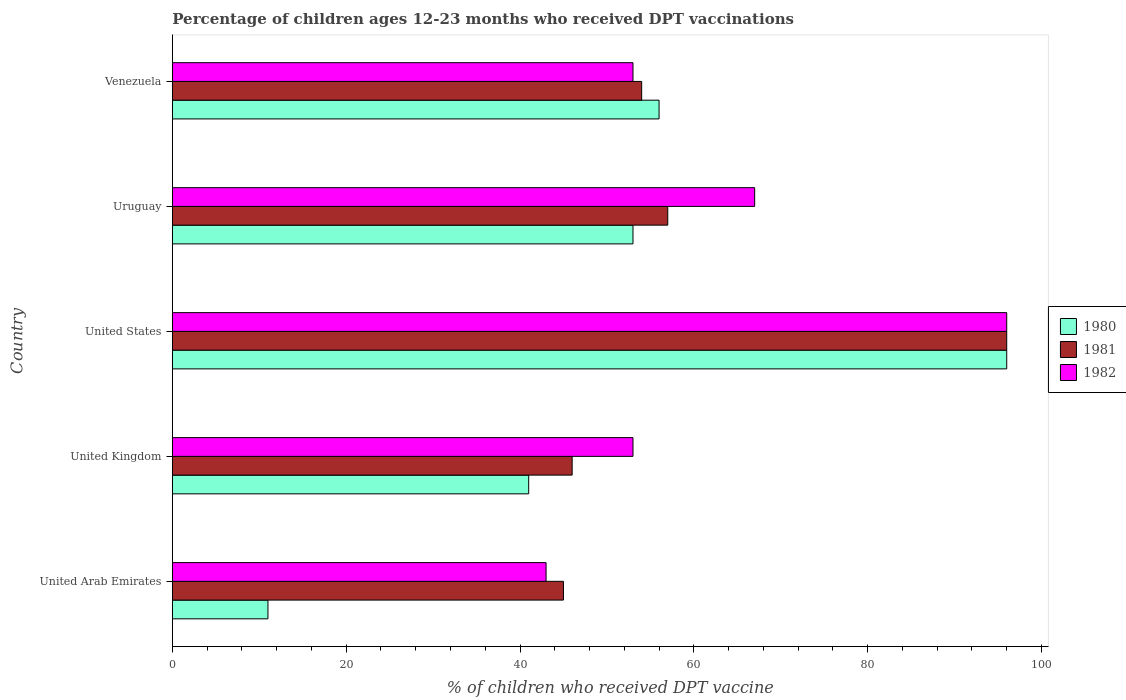How many groups of bars are there?
Offer a very short reply. 5. Are the number of bars on each tick of the Y-axis equal?
Ensure brevity in your answer.  Yes. How many bars are there on the 4th tick from the top?
Provide a succinct answer. 3. What is the label of the 5th group of bars from the top?
Give a very brief answer. United Arab Emirates. In how many cases, is the number of bars for a given country not equal to the number of legend labels?
Your answer should be compact. 0. What is the percentage of children who received DPT vaccination in 1980 in United Arab Emirates?
Keep it short and to the point. 11. Across all countries, what is the maximum percentage of children who received DPT vaccination in 1982?
Offer a terse response. 96. Across all countries, what is the minimum percentage of children who received DPT vaccination in 1982?
Ensure brevity in your answer.  43. In which country was the percentage of children who received DPT vaccination in 1982 maximum?
Provide a short and direct response. United States. In which country was the percentage of children who received DPT vaccination in 1981 minimum?
Offer a terse response. United Arab Emirates. What is the total percentage of children who received DPT vaccination in 1980 in the graph?
Offer a terse response. 257. What is the difference between the percentage of children who received DPT vaccination in 1981 in United Arab Emirates and the percentage of children who received DPT vaccination in 1980 in Uruguay?
Your response must be concise. -8. What is the average percentage of children who received DPT vaccination in 1980 per country?
Your answer should be very brief. 51.4. What is the difference between the percentage of children who received DPT vaccination in 1980 and percentage of children who received DPT vaccination in 1982 in United Kingdom?
Give a very brief answer. -12. In how many countries, is the percentage of children who received DPT vaccination in 1982 greater than 92 %?
Your answer should be very brief. 1. What is the ratio of the percentage of children who received DPT vaccination in 1982 in Uruguay to that in Venezuela?
Give a very brief answer. 1.26. Is the difference between the percentage of children who received DPT vaccination in 1980 in United Arab Emirates and United Kingdom greater than the difference between the percentage of children who received DPT vaccination in 1982 in United Arab Emirates and United Kingdom?
Provide a succinct answer. No. In how many countries, is the percentage of children who received DPT vaccination in 1980 greater than the average percentage of children who received DPT vaccination in 1980 taken over all countries?
Offer a very short reply. 3. Are all the bars in the graph horizontal?
Give a very brief answer. Yes. Are the values on the major ticks of X-axis written in scientific E-notation?
Your answer should be compact. No. How many legend labels are there?
Offer a terse response. 3. How are the legend labels stacked?
Make the answer very short. Vertical. What is the title of the graph?
Provide a succinct answer. Percentage of children ages 12-23 months who received DPT vaccinations. Does "2010" appear as one of the legend labels in the graph?
Your response must be concise. No. What is the label or title of the X-axis?
Your response must be concise. % of children who received DPT vaccine. What is the label or title of the Y-axis?
Your response must be concise. Country. What is the % of children who received DPT vaccine of 1980 in United Arab Emirates?
Provide a succinct answer. 11. What is the % of children who received DPT vaccine of 1980 in United Kingdom?
Provide a succinct answer. 41. What is the % of children who received DPT vaccine in 1982 in United Kingdom?
Offer a terse response. 53. What is the % of children who received DPT vaccine in 1980 in United States?
Offer a terse response. 96. What is the % of children who received DPT vaccine of 1981 in United States?
Your response must be concise. 96. What is the % of children who received DPT vaccine of 1982 in United States?
Offer a very short reply. 96. What is the % of children who received DPT vaccine of 1980 in Uruguay?
Your answer should be compact. 53. What is the % of children who received DPT vaccine in 1981 in Uruguay?
Offer a terse response. 57. What is the % of children who received DPT vaccine in 1980 in Venezuela?
Your answer should be very brief. 56. What is the % of children who received DPT vaccine in 1981 in Venezuela?
Your answer should be compact. 54. Across all countries, what is the maximum % of children who received DPT vaccine of 1980?
Your answer should be compact. 96. Across all countries, what is the maximum % of children who received DPT vaccine of 1981?
Your answer should be compact. 96. Across all countries, what is the maximum % of children who received DPT vaccine of 1982?
Offer a terse response. 96. Across all countries, what is the minimum % of children who received DPT vaccine of 1980?
Ensure brevity in your answer.  11. Across all countries, what is the minimum % of children who received DPT vaccine of 1981?
Your answer should be very brief. 45. Across all countries, what is the minimum % of children who received DPT vaccine in 1982?
Keep it short and to the point. 43. What is the total % of children who received DPT vaccine in 1980 in the graph?
Keep it short and to the point. 257. What is the total % of children who received DPT vaccine in 1981 in the graph?
Offer a terse response. 298. What is the total % of children who received DPT vaccine in 1982 in the graph?
Ensure brevity in your answer.  312. What is the difference between the % of children who received DPT vaccine in 1982 in United Arab Emirates and that in United Kingdom?
Offer a very short reply. -10. What is the difference between the % of children who received DPT vaccine of 1980 in United Arab Emirates and that in United States?
Make the answer very short. -85. What is the difference between the % of children who received DPT vaccine of 1981 in United Arab Emirates and that in United States?
Make the answer very short. -51. What is the difference between the % of children who received DPT vaccine of 1982 in United Arab Emirates and that in United States?
Provide a succinct answer. -53. What is the difference between the % of children who received DPT vaccine of 1980 in United Arab Emirates and that in Uruguay?
Offer a very short reply. -42. What is the difference between the % of children who received DPT vaccine of 1981 in United Arab Emirates and that in Uruguay?
Provide a short and direct response. -12. What is the difference between the % of children who received DPT vaccine of 1980 in United Arab Emirates and that in Venezuela?
Your response must be concise. -45. What is the difference between the % of children who received DPT vaccine of 1980 in United Kingdom and that in United States?
Provide a succinct answer. -55. What is the difference between the % of children who received DPT vaccine of 1981 in United Kingdom and that in United States?
Provide a succinct answer. -50. What is the difference between the % of children who received DPT vaccine of 1982 in United Kingdom and that in United States?
Give a very brief answer. -43. What is the difference between the % of children who received DPT vaccine of 1980 in United Kingdom and that in Uruguay?
Offer a terse response. -12. What is the difference between the % of children who received DPT vaccine in 1981 in United Kingdom and that in Uruguay?
Offer a terse response. -11. What is the difference between the % of children who received DPT vaccine of 1981 in United States and that in Venezuela?
Your answer should be very brief. 42. What is the difference between the % of children who received DPT vaccine of 1982 in United States and that in Venezuela?
Keep it short and to the point. 43. What is the difference between the % of children who received DPT vaccine of 1980 in Uruguay and that in Venezuela?
Keep it short and to the point. -3. What is the difference between the % of children who received DPT vaccine in 1980 in United Arab Emirates and the % of children who received DPT vaccine in 1981 in United Kingdom?
Provide a succinct answer. -35. What is the difference between the % of children who received DPT vaccine of 1980 in United Arab Emirates and the % of children who received DPT vaccine of 1982 in United Kingdom?
Your response must be concise. -42. What is the difference between the % of children who received DPT vaccine of 1980 in United Arab Emirates and the % of children who received DPT vaccine of 1981 in United States?
Make the answer very short. -85. What is the difference between the % of children who received DPT vaccine in 1980 in United Arab Emirates and the % of children who received DPT vaccine in 1982 in United States?
Give a very brief answer. -85. What is the difference between the % of children who received DPT vaccine of 1981 in United Arab Emirates and the % of children who received DPT vaccine of 1982 in United States?
Provide a short and direct response. -51. What is the difference between the % of children who received DPT vaccine of 1980 in United Arab Emirates and the % of children who received DPT vaccine of 1981 in Uruguay?
Keep it short and to the point. -46. What is the difference between the % of children who received DPT vaccine in 1980 in United Arab Emirates and the % of children who received DPT vaccine in 1982 in Uruguay?
Make the answer very short. -56. What is the difference between the % of children who received DPT vaccine in 1981 in United Arab Emirates and the % of children who received DPT vaccine in 1982 in Uruguay?
Offer a terse response. -22. What is the difference between the % of children who received DPT vaccine of 1980 in United Arab Emirates and the % of children who received DPT vaccine of 1981 in Venezuela?
Provide a succinct answer. -43. What is the difference between the % of children who received DPT vaccine in 1980 in United Arab Emirates and the % of children who received DPT vaccine in 1982 in Venezuela?
Offer a terse response. -42. What is the difference between the % of children who received DPT vaccine in 1981 in United Arab Emirates and the % of children who received DPT vaccine in 1982 in Venezuela?
Your answer should be very brief. -8. What is the difference between the % of children who received DPT vaccine of 1980 in United Kingdom and the % of children who received DPT vaccine of 1981 in United States?
Offer a terse response. -55. What is the difference between the % of children who received DPT vaccine of 1980 in United Kingdom and the % of children who received DPT vaccine of 1982 in United States?
Your response must be concise. -55. What is the difference between the % of children who received DPT vaccine in 1980 in United Kingdom and the % of children who received DPT vaccine in 1982 in Uruguay?
Your answer should be compact. -26. What is the difference between the % of children who received DPT vaccine of 1981 in United Kingdom and the % of children who received DPT vaccine of 1982 in Uruguay?
Provide a succinct answer. -21. What is the difference between the % of children who received DPT vaccine of 1981 in United States and the % of children who received DPT vaccine of 1982 in Uruguay?
Your answer should be compact. 29. What is the difference between the % of children who received DPT vaccine of 1980 in United States and the % of children who received DPT vaccine of 1981 in Venezuela?
Make the answer very short. 42. What is the difference between the % of children who received DPT vaccine in 1980 in United States and the % of children who received DPT vaccine in 1982 in Venezuela?
Your response must be concise. 43. What is the difference between the % of children who received DPT vaccine in 1981 in United States and the % of children who received DPT vaccine in 1982 in Venezuela?
Keep it short and to the point. 43. What is the difference between the % of children who received DPT vaccine in 1980 in Uruguay and the % of children who received DPT vaccine in 1981 in Venezuela?
Your answer should be compact. -1. What is the difference between the % of children who received DPT vaccine of 1981 in Uruguay and the % of children who received DPT vaccine of 1982 in Venezuela?
Offer a terse response. 4. What is the average % of children who received DPT vaccine in 1980 per country?
Your answer should be very brief. 51.4. What is the average % of children who received DPT vaccine of 1981 per country?
Give a very brief answer. 59.6. What is the average % of children who received DPT vaccine in 1982 per country?
Your response must be concise. 62.4. What is the difference between the % of children who received DPT vaccine of 1980 and % of children who received DPT vaccine of 1981 in United Arab Emirates?
Your answer should be compact. -34. What is the difference between the % of children who received DPT vaccine in 1980 and % of children who received DPT vaccine in 1982 in United Arab Emirates?
Provide a short and direct response. -32. What is the difference between the % of children who received DPT vaccine in 1980 and % of children who received DPT vaccine in 1981 in United States?
Your answer should be compact. 0. What is the difference between the % of children who received DPT vaccine of 1981 and % of children who received DPT vaccine of 1982 in United States?
Provide a short and direct response. 0. What is the difference between the % of children who received DPT vaccine of 1980 and % of children who received DPT vaccine of 1981 in Uruguay?
Your answer should be very brief. -4. What is the difference between the % of children who received DPT vaccine of 1980 and % of children who received DPT vaccine of 1982 in Venezuela?
Ensure brevity in your answer.  3. What is the difference between the % of children who received DPT vaccine in 1981 and % of children who received DPT vaccine in 1982 in Venezuela?
Ensure brevity in your answer.  1. What is the ratio of the % of children who received DPT vaccine in 1980 in United Arab Emirates to that in United Kingdom?
Provide a succinct answer. 0.27. What is the ratio of the % of children who received DPT vaccine of 1981 in United Arab Emirates to that in United Kingdom?
Your response must be concise. 0.98. What is the ratio of the % of children who received DPT vaccine in 1982 in United Arab Emirates to that in United Kingdom?
Ensure brevity in your answer.  0.81. What is the ratio of the % of children who received DPT vaccine of 1980 in United Arab Emirates to that in United States?
Your response must be concise. 0.11. What is the ratio of the % of children who received DPT vaccine of 1981 in United Arab Emirates to that in United States?
Your answer should be compact. 0.47. What is the ratio of the % of children who received DPT vaccine of 1982 in United Arab Emirates to that in United States?
Offer a very short reply. 0.45. What is the ratio of the % of children who received DPT vaccine in 1980 in United Arab Emirates to that in Uruguay?
Your answer should be compact. 0.21. What is the ratio of the % of children who received DPT vaccine of 1981 in United Arab Emirates to that in Uruguay?
Keep it short and to the point. 0.79. What is the ratio of the % of children who received DPT vaccine in 1982 in United Arab Emirates to that in Uruguay?
Your answer should be very brief. 0.64. What is the ratio of the % of children who received DPT vaccine of 1980 in United Arab Emirates to that in Venezuela?
Give a very brief answer. 0.2. What is the ratio of the % of children who received DPT vaccine in 1982 in United Arab Emirates to that in Venezuela?
Your answer should be very brief. 0.81. What is the ratio of the % of children who received DPT vaccine in 1980 in United Kingdom to that in United States?
Provide a succinct answer. 0.43. What is the ratio of the % of children who received DPT vaccine of 1981 in United Kingdom to that in United States?
Your response must be concise. 0.48. What is the ratio of the % of children who received DPT vaccine in 1982 in United Kingdom to that in United States?
Provide a succinct answer. 0.55. What is the ratio of the % of children who received DPT vaccine of 1980 in United Kingdom to that in Uruguay?
Provide a short and direct response. 0.77. What is the ratio of the % of children who received DPT vaccine of 1981 in United Kingdom to that in Uruguay?
Give a very brief answer. 0.81. What is the ratio of the % of children who received DPT vaccine of 1982 in United Kingdom to that in Uruguay?
Provide a succinct answer. 0.79. What is the ratio of the % of children who received DPT vaccine of 1980 in United Kingdom to that in Venezuela?
Ensure brevity in your answer.  0.73. What is the ratio of the % of children who received DPT vaccine in 1981 in United Kingdom to that in Venezuela?
Your response must be concise. 0.85. What is the ratio of the % of children who received DPT vaccine of 1980 in United States to that in Uruguay?
Your response must be concise. 1.81. What is the ratio of the % of children who received DPT vaccine of 1981 in United States to that in Uruguay?
Your answer should be compact. 1.68. What is the ratio of the % of children who received DPT vaccine in 1982 in United States to that in Uruguay?
Give a very brief answer. 1.43. What is the ratio of the % of children who received DPT vaccine of 1980 in United States to that in Venezuela?
Make the answer very short. 1.71. What is the ratio of the % of children who received DPT vaccine in 1981 in United States to that in Venezuela?
Ensure brevity in your answer.  1.78. What is the ratio of the % of children who received DPT vaccine of 1982 in United States to that in Venezuela?
Offer a terse response. 1.81. What is the ratio of the % of children who received DPT vaccine of 1980 in Uruguay to that in Venezuela?
Your response must be concise. 0.95. What is the ratio of the % of children who received DPT vaccine of 1981 in Uruguay to that in Venezuela?
Keep it short and to the point. 1.06. What is the ratio of the % of children who received DPT vaccine in 1982 in Uruguay to that in Venezuela?
Offer a terse response. 1.26. What is the difference between the highest and the second highest % of children who received DPT vaccine in 1981?
Provide a succinct answer. 39. 